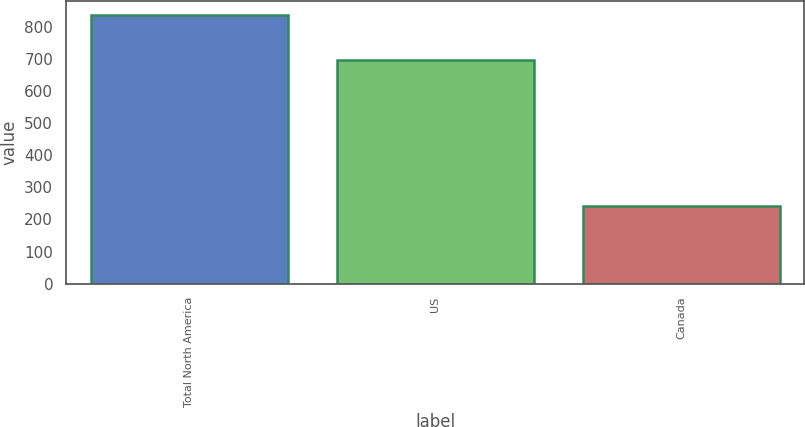Convert chart. <chart><loc_0><loc_0><loc_500><loc_500><bar_chart><fcel>Total North America<fcel>US<fcel>Canada<nl><fcel>838.7<fcel>698.7<fcel>241.6<nl></chart> 